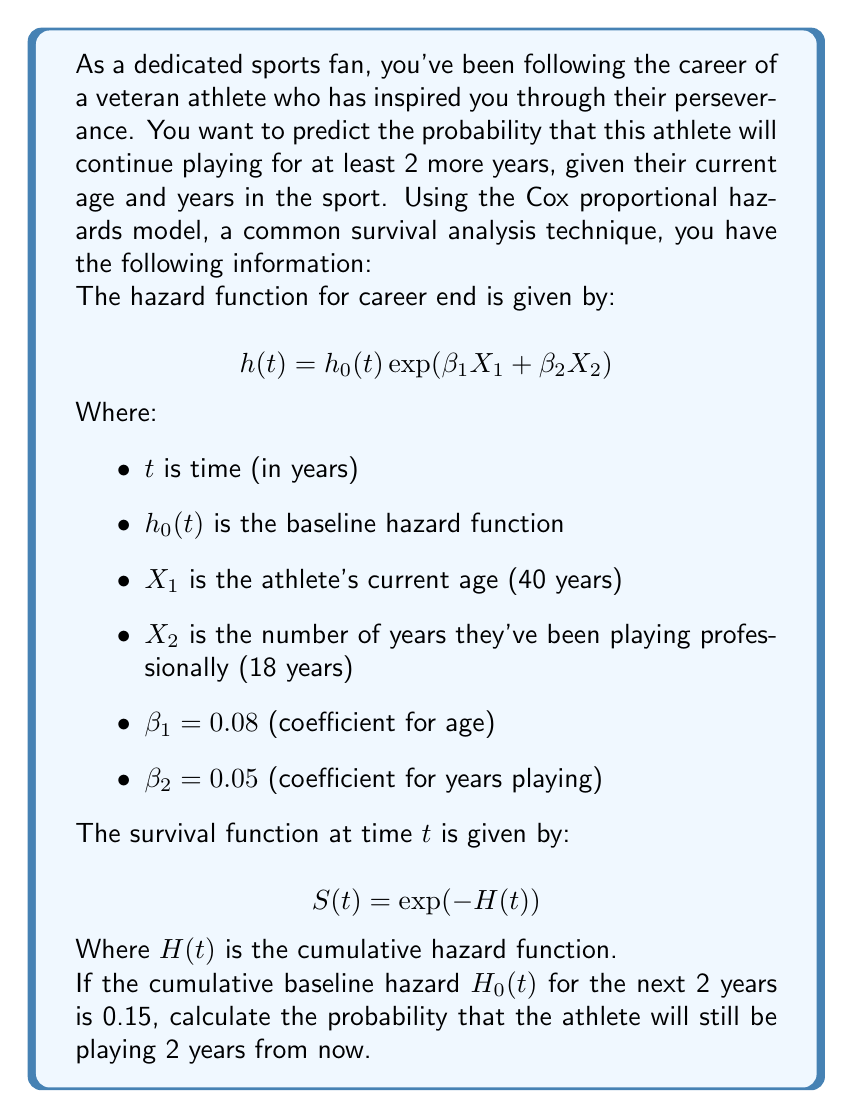Solve this math problem. Let's approach this step-by-step:

1) First, we need to calculate the linear predictor part of the Cox model:

   $\beta_1 X_1 + \beta_2 X_2 = (0.08 \times 40) + (0.05 \times 18) = 3.2 + 0.9 = 4.1$

2) Now, we can calculate the cumulative hazard function for our athlete:

   $H(t) = H_0(t) \exp(\beta_1 X_1 + \beta_2 X_2)$
   $H(t) = 0.15 \times \exp(4.1)$
   $H(t) = 0.15 \times 60.34 = 9.051$

3) The survival function is given by:

   $S(t) = \exp(-H(t))$
   $S(t) = \exp(-9.051)$
   $S(t) = 0.000117$

4) This survival function value represents the probability that the athlete will still be playing 2 years from now.

5) To express this as a percentage, we multiply by 100:

   $0.000117 \times 100 = 0.0117\%$
Answer: 0.0117% 